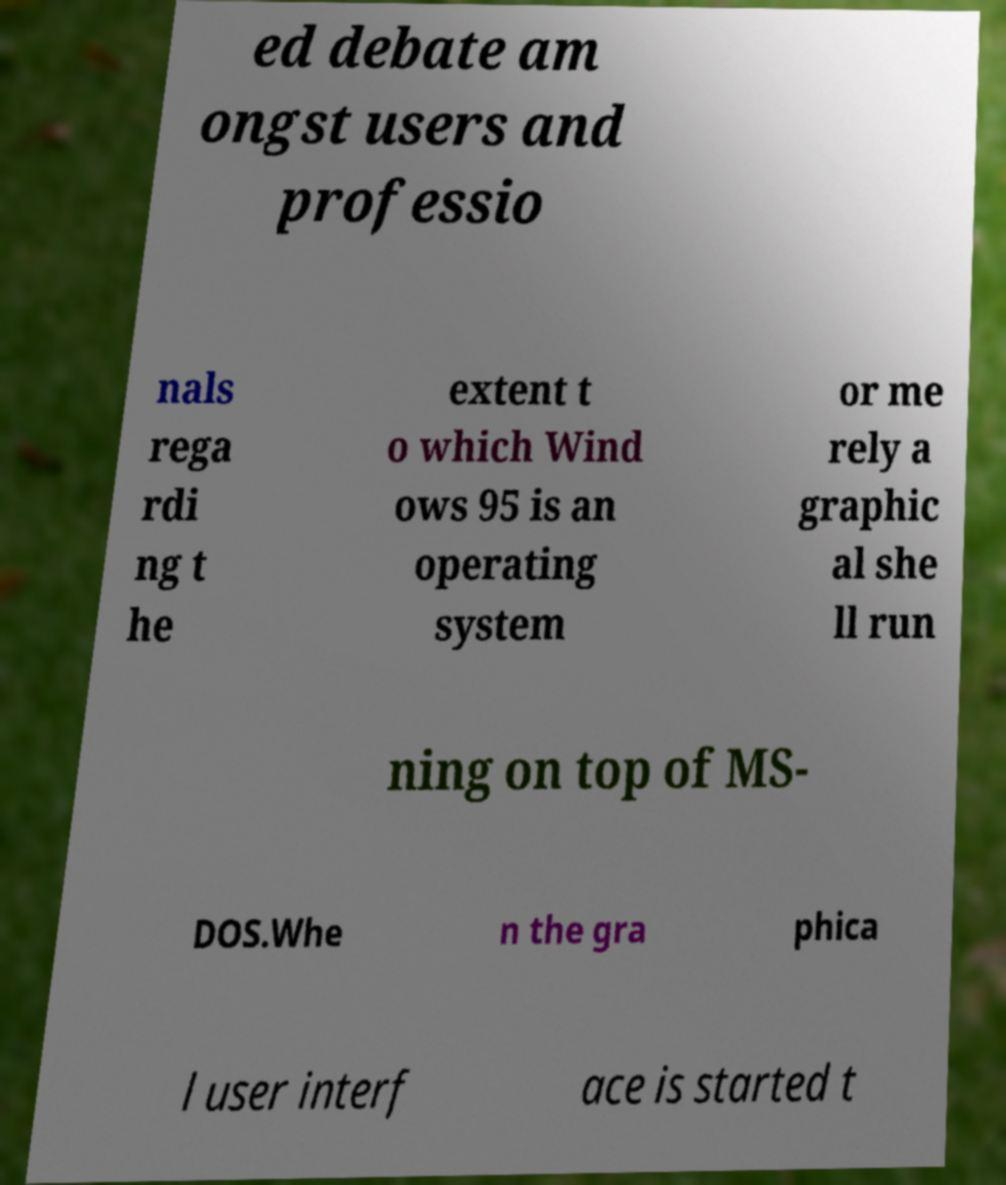Can you accurately transcribe the text from the provided image for me? ed debate am ongst users and professio nals rega rdi ng t he extent t o which Wind ows 95 is an operating system or me rely a graphic al she ll run ning on top of MS- DOS.Whe n the gra phica l user interf ace is started t 